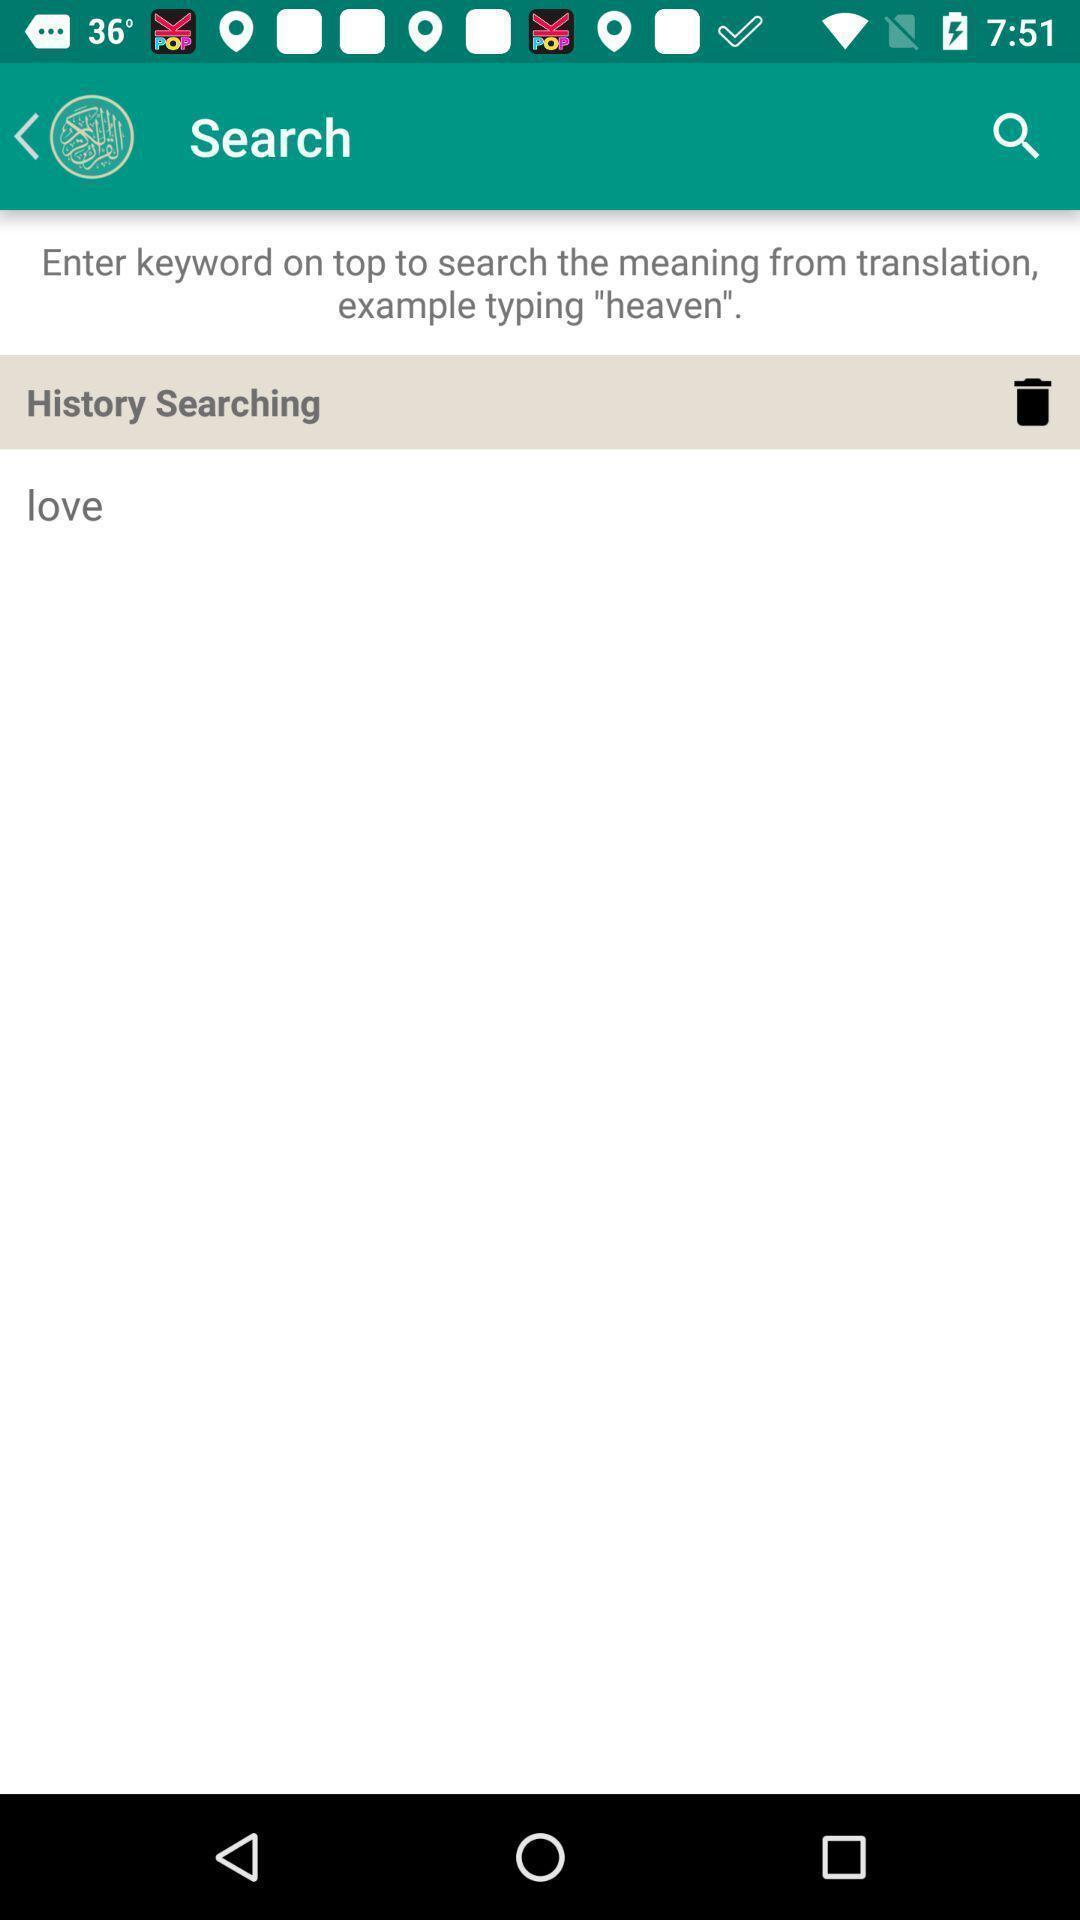Explain the elements present in this screenshot. Page showing search history on a translation app. 